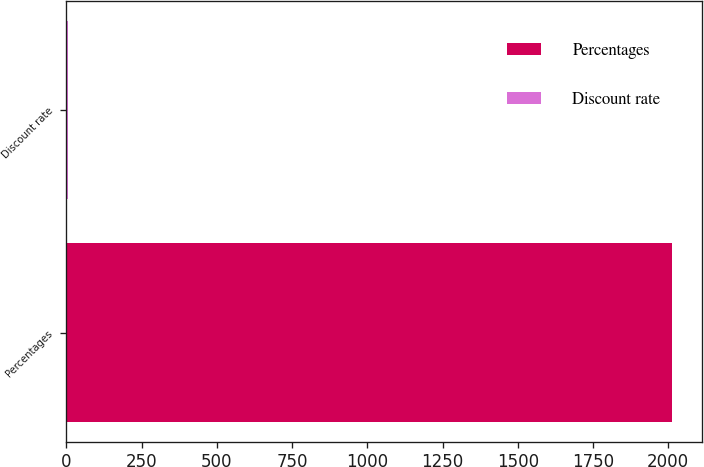<chart> <loc_0><loc_0><loc_500><loc_500><bar_chart><fcel>Percentages<fcel>Discount rate<nl><fcel>2012<fcel>4.36<nl></chart> 